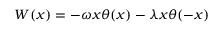<formula> <loc_0><loc_0><loc_500><loc_500>W ( x ) = - \omega x \theta ( x ) - \lambda x \theta ( - x )</formula> 